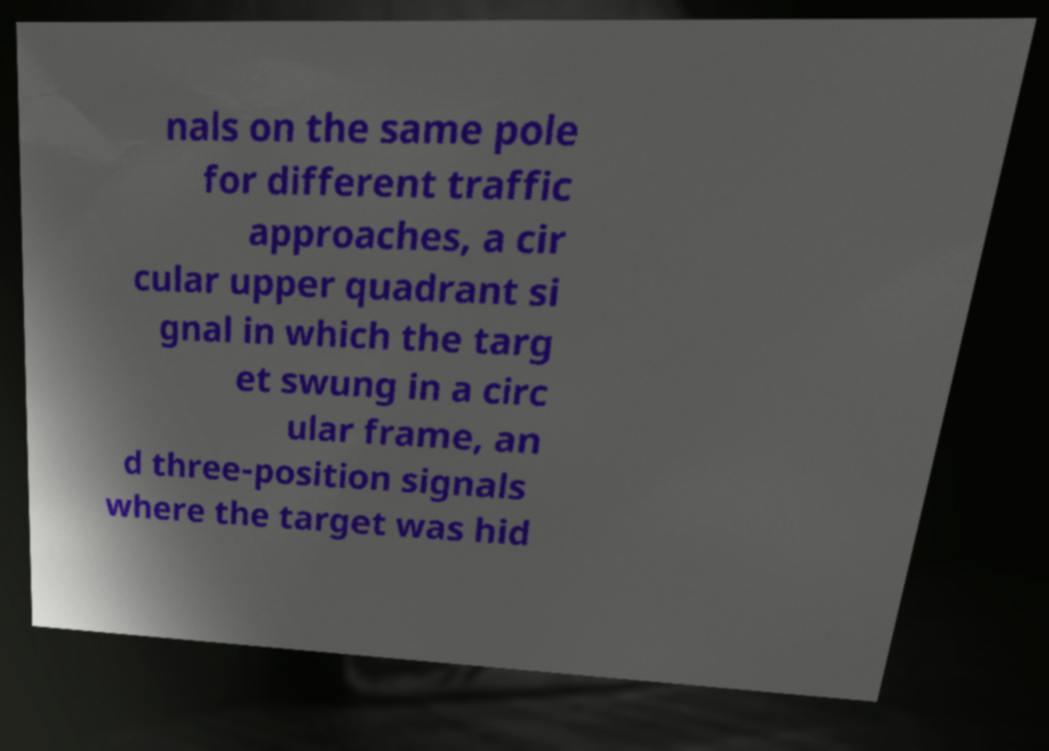Could you assist in decoding the text presented in this image and type it out clearly? nals on the same pole for different traffic approaches, a cir cular upper quadrant si gnal in which the targ et swung in a circ ular frame, an d three-position signals where the target was hid 